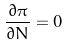Convert formula to latex. <formula><loc_0><loc_0><loc_500><loc_500>\frac { \partial \pi } { \partial N } = 0</formula> 